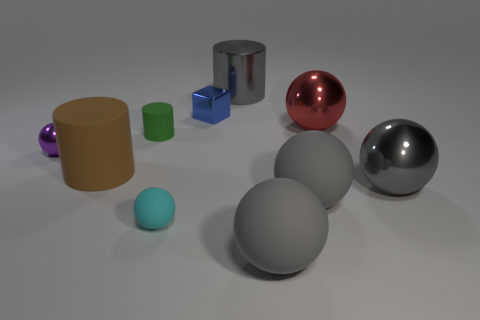Subtract all small cyan balls. How many balls are left? 5 Subtract all purple balls. How many balls are left? 5 Subtract all cylinders. How many objects are left? 7 Subtract 4 balls. How many balls are left? 2 Subtract all blue cylinders. Subtract all green cubes. How many cylinders are left? 3 Subtract all blue cubes. How many brown balls are left? 0 Subtract all tiny cyan spheres. Subtract all cubes. How many objects are left? 8 Add 4 balls. How many balls are left? 10 Add 7 red objects. How many red objects exist? 8 Subtract 0 green spheres. How many objects are left? 10 